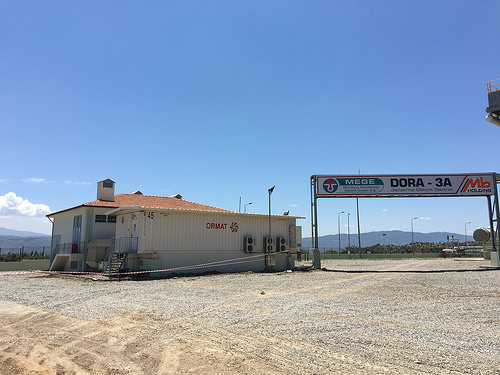<image>
Is there a sky on the ground? No. The sky is not positioned on the ground. They may be near each other, but the sky is not supported by or resting on top of the ground. Is there a pole behind the building? No. The pole is not behind the building. From this viewpoint, the pole appears to be positioned elsewhere in the scene. 